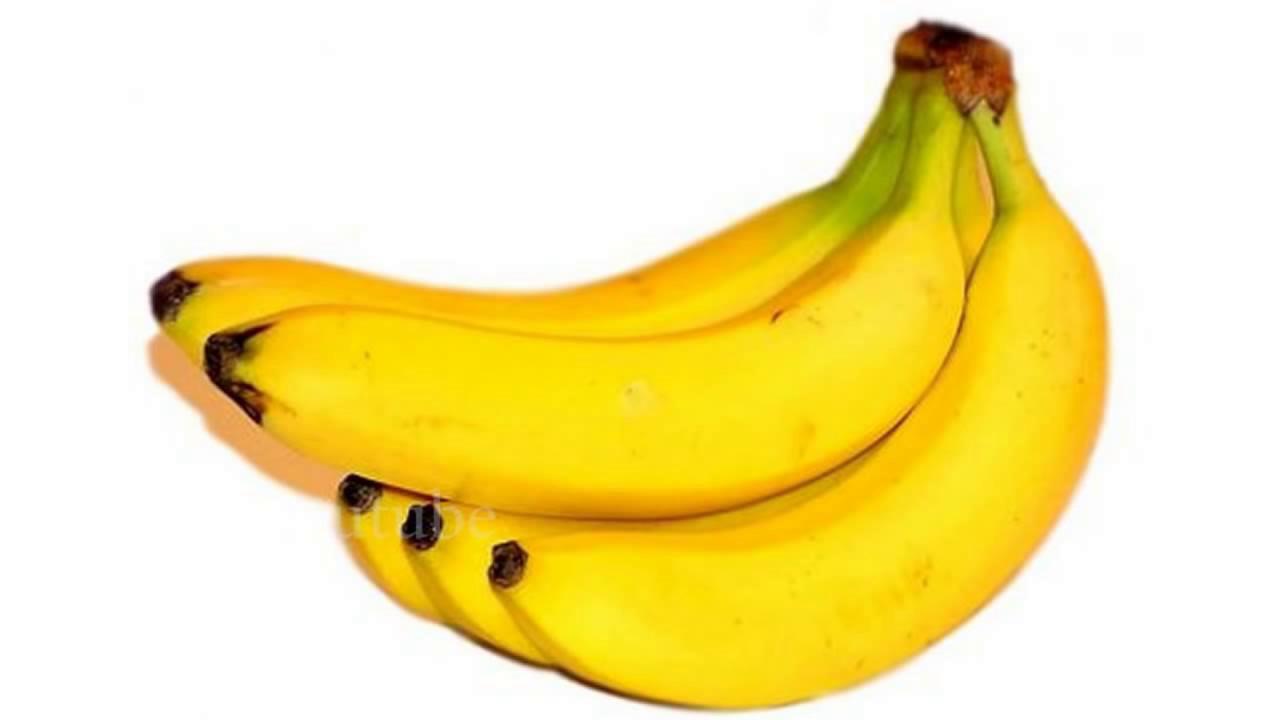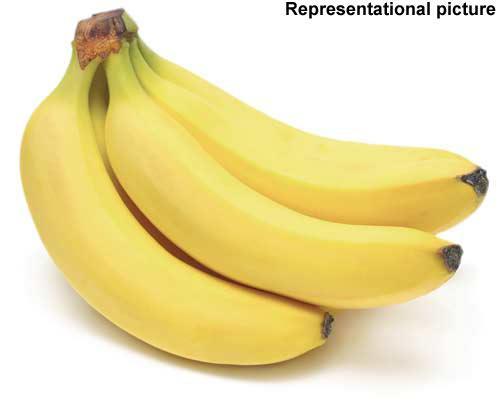The first image is the image on the left, the second image is the image on the right. Assess this claim about the two images: "In one image, the inside of a banana is visible.". Correct or not? Answer yes or no. No. The first image is the image on the left, the second image is the image on the right. Assess this claim about the two images: "The left image includes unpeeled bananas with at least one other item, and the right image shows what is under a banana peel.". Correct or not? Answer yes or no. No. 